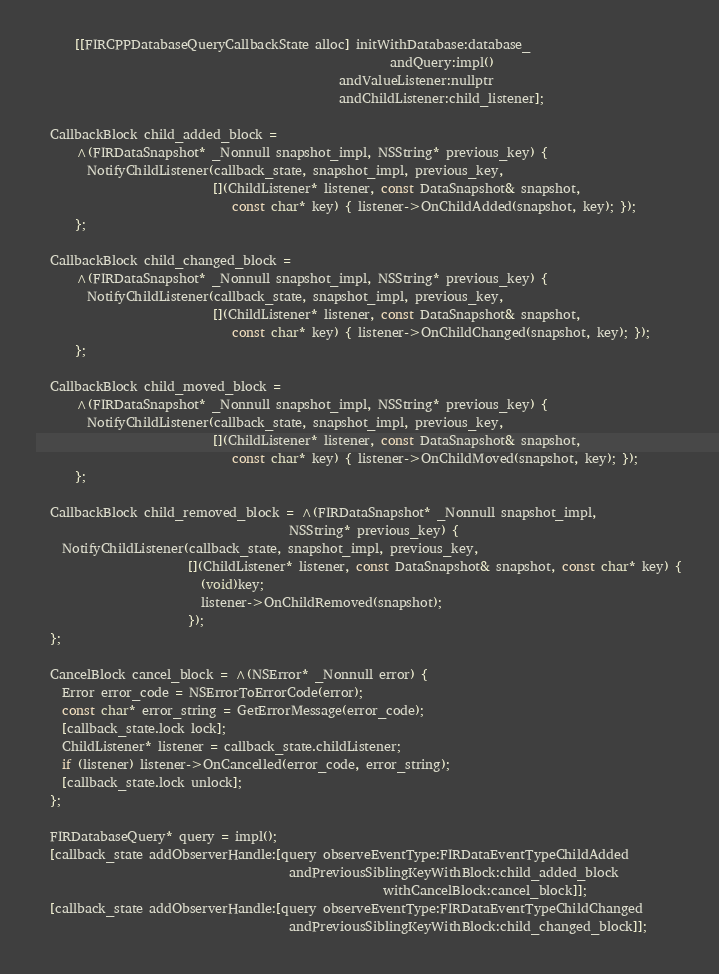Convert code to text. <code><loc_0><loc_0><loc_500><loc_500><_ObjectiveC_>      [[FIRCPPDatabaseQueryCallbackState alloc] initWithDatabase:database_
                                                        andQuery:impl()
                                                andValueListener:nullptr
                                                andChildListener:child_listener];

  CallbackBlock child_added_block =
      ^(FIRDataSnapshot* _Nonnull snapshot_impl, NSString* previous_key) {
        NotifyChildListener(callback_state, snapshot_impl, previous_key,
                            [](ChildListener* listener, const DataSnapshot& snapshot,
                               const char* key) { listener->OnChildAdded(snapshot, key); });
      };

  CallbackBlock child_changed_block =
      ^(FIRDataSnapshot* _Nonnull snapshot_impl, NSString* previous_key) {
        NotifyChildListener(callback_state, snapshot_impl, previous_key,
                            [](ChildListener* listener, const DataSnapshot& snapshot,
                               const char* key) { listener->OnChildChanged(snapshot, key); });
      };

  CallbackBlock child_moved_block =
      ^(FIRDataSnapshot* _Nonnull snapshot_impl, NSString* previous_key) {
        NotifyChildListener(callback_state, snapshot_impl, previous_key,
                            [](ChildListener* listener, const DataSnapshot& snapshot,
                               const char* key) { listener->OnChildMoved(snapshot, key); });
      };

  CallbackBlock child_removed_block = ^(FIRDataSnapshot* _Nonnull snapshot_impl,
                                        NSString* previous_key) {
    NotifyChildListener(callback_state, snapshot_impl, previous_key,
                        [](ChildListener* listener, const DataSnapshot& snapshot, const char* key) {
                          (void)key;
                          listener->OnChildRemoved(snapshot);
                        });
  };

  CancelBlock cancel_block = ^(NSError* _Nonnull error) {
    Error error_code = NSErrorToErrorCode(error);
    const char* error_string = GetErrorMessage(error_code);
    [callback_state.lock lock];
    ChildListener* listener = callback_state.childListener;
    if (listener) listener->OnCancelled(error_code, error_string);
    [callback_state.lock unlock];
  };

  FIRDatabaseQuery* query = impl();
  [callback_state addObserverHandle:[query observeEventType:FIRDataEventTypeChildAdded
                                        andPreviousSiblingKeyWithBlock:child_added_block
                                                       withCancelBlock:cancel_block]];
  [callback_state addObserverHandle:[query observeEventType:FIRDataEventTypeChildChanged
                                        andPreviousSiblingKeyWithBlock:child_changed_block]];</code> 